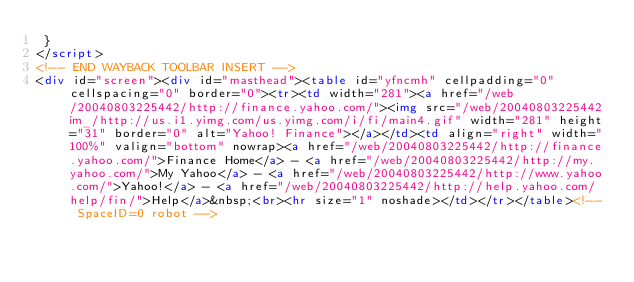<code> <loc_0><loc_0><loc_500><loc_500><_HTML_> }
</script>
<!-- END WAYBACK TOOLBAR INSERT -->
<div id="screen"><div id="masthead"><table id="yfncmh" cellpadding="0" cellspacing="0" border="0"><tr><td width="281"><a href="/web/20040803225442/http://finance.yahoo.com/"><img src="/web/20040803225442im_/http://us.i1.yimg.com/us.yimg.com/i/fi/main4.gif" width="281" height="31" border="0" alt="Yahoo! Finance"></a></td><td align="right" width="100%" valign="bottom" nowrap><a href="/web/20040803225442/http://finance.yahoo.com/">Finance Home</a> - <a href="/web/20040803225442/http://my.yahoo.com/">My Yahoo</a> - <a href="/web/20040803225442/http://www.yahoo.com/">Yahoo!</a> - <a href="/web/20040803225442/http://help.yahoo.com/help/fin/">Help</a>&nbsp;<br><hr size="1" noshade></td></tr></table><!-- SpaceID=0 robot --></code> 